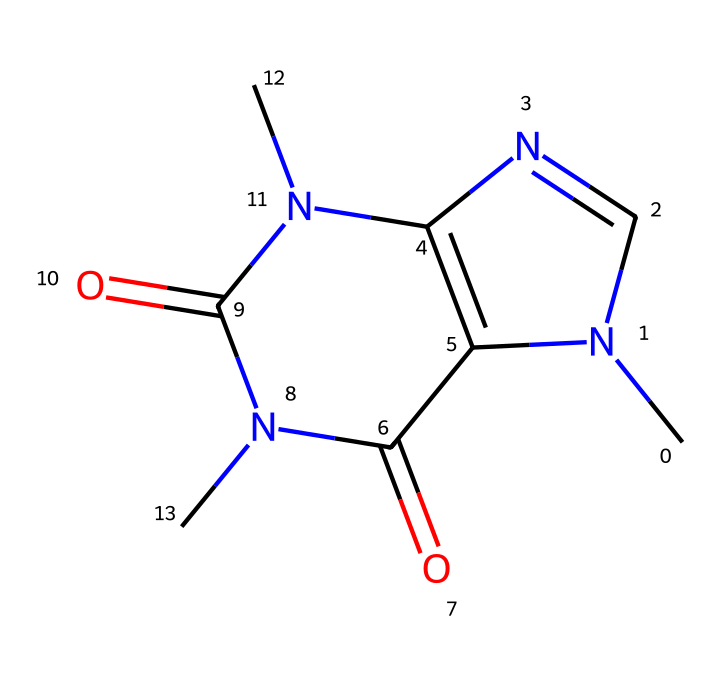What is the name of the chemical represented? The SMILES representation corresponds to caffeine, a well-known stimulant found in coffee.
Answer: caffeine How many nitrogen atoms are present in this structure? By analyzing the SMILES representation, we find there are four nitrogen atoms denoted by the 'N' symbols.
Answer: four What are the total number of rings in this chemical structure? The analysis shows there are two fused rings in the structure, identifiable through the 'C' and 'N' connections without any open-chain structures.
Answer: two What type of functional groups are present in caffeine? The structure features carbonyl (C=O) groups, recognized through their double bonds with oxygen (found in the N-C(=O) and C(=O)-N linkages), which are characteristic of amides.
Answer: amides Is caffeine a polar or nonpolar molecule? Considering the presence of polar functional groups (like carbonyls and nitrogen atoms), caffeine exhibits polar characteristics.
Answer: polar How does caffeine likely affect the central nervous system? Due to the presence of nitrogen atoms that interact with adenosine receptors, caffeine acts as an antagonist, which indicates a stimulating effect on the central nervous system.
Answer: stimulating What effect does the structure of caffeine have on its solubility in water? The polar nitrogens and carbonyls contribute to the solubility of caffeine in water, as polar compounds generally dissolve well in polar solvents.
Answer: soluble 